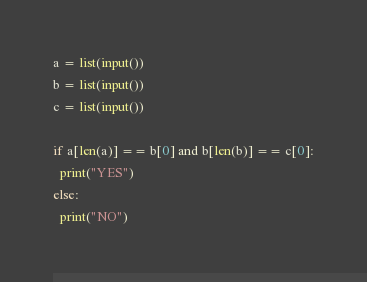<code> <loc_0><loc_0><loc_500><loc_500><_Python_>a = list(input())
b = list(input())
c = list(input())

if a[len(a)] == b[0] and b[len(b)] == c[0]:
  print("YES")
else:
  print("NO")</code> 